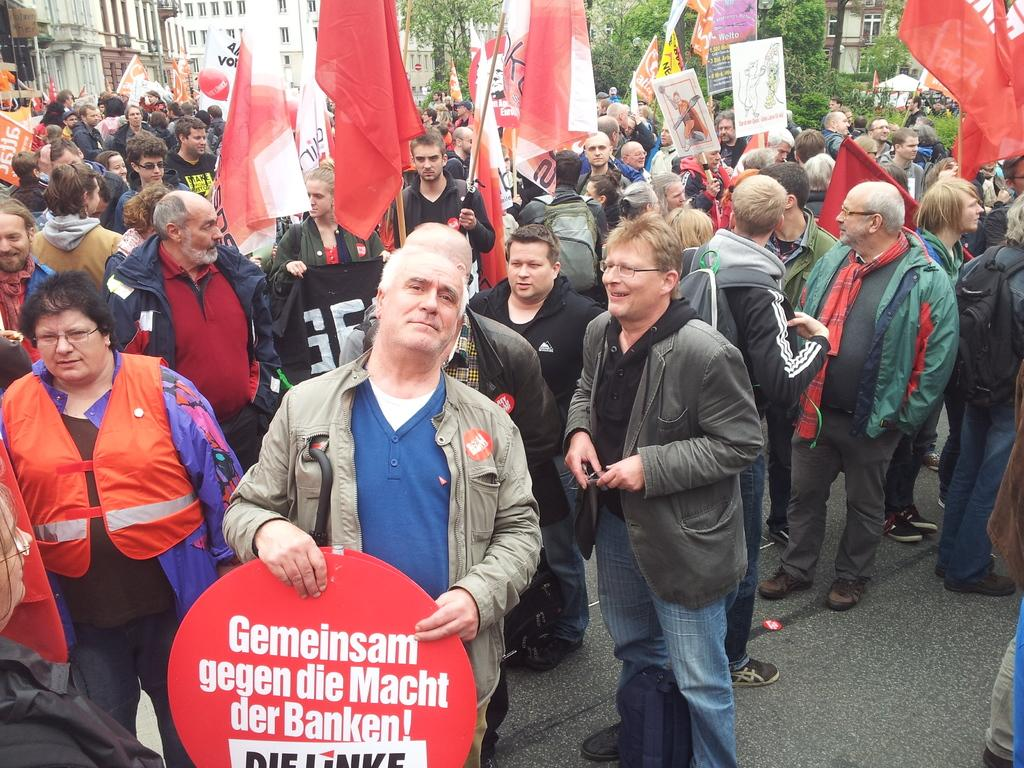What are the people in the image doing? There is a group of people standing on the road in the image. What can be seen in the image besides the people? There are flags, posters, spectacles, bags, and jackets visible in the image. What is visible in the background of the image? There are buildings with windows and trees in the background of the image. How many cent coins are visible on the ground in the image? There are no cent coins visible on the ground in the image. What type of visitor can be seen interacting with the people in the image? There is no visitor present in the image; it only shows a group of people standing on the road. 